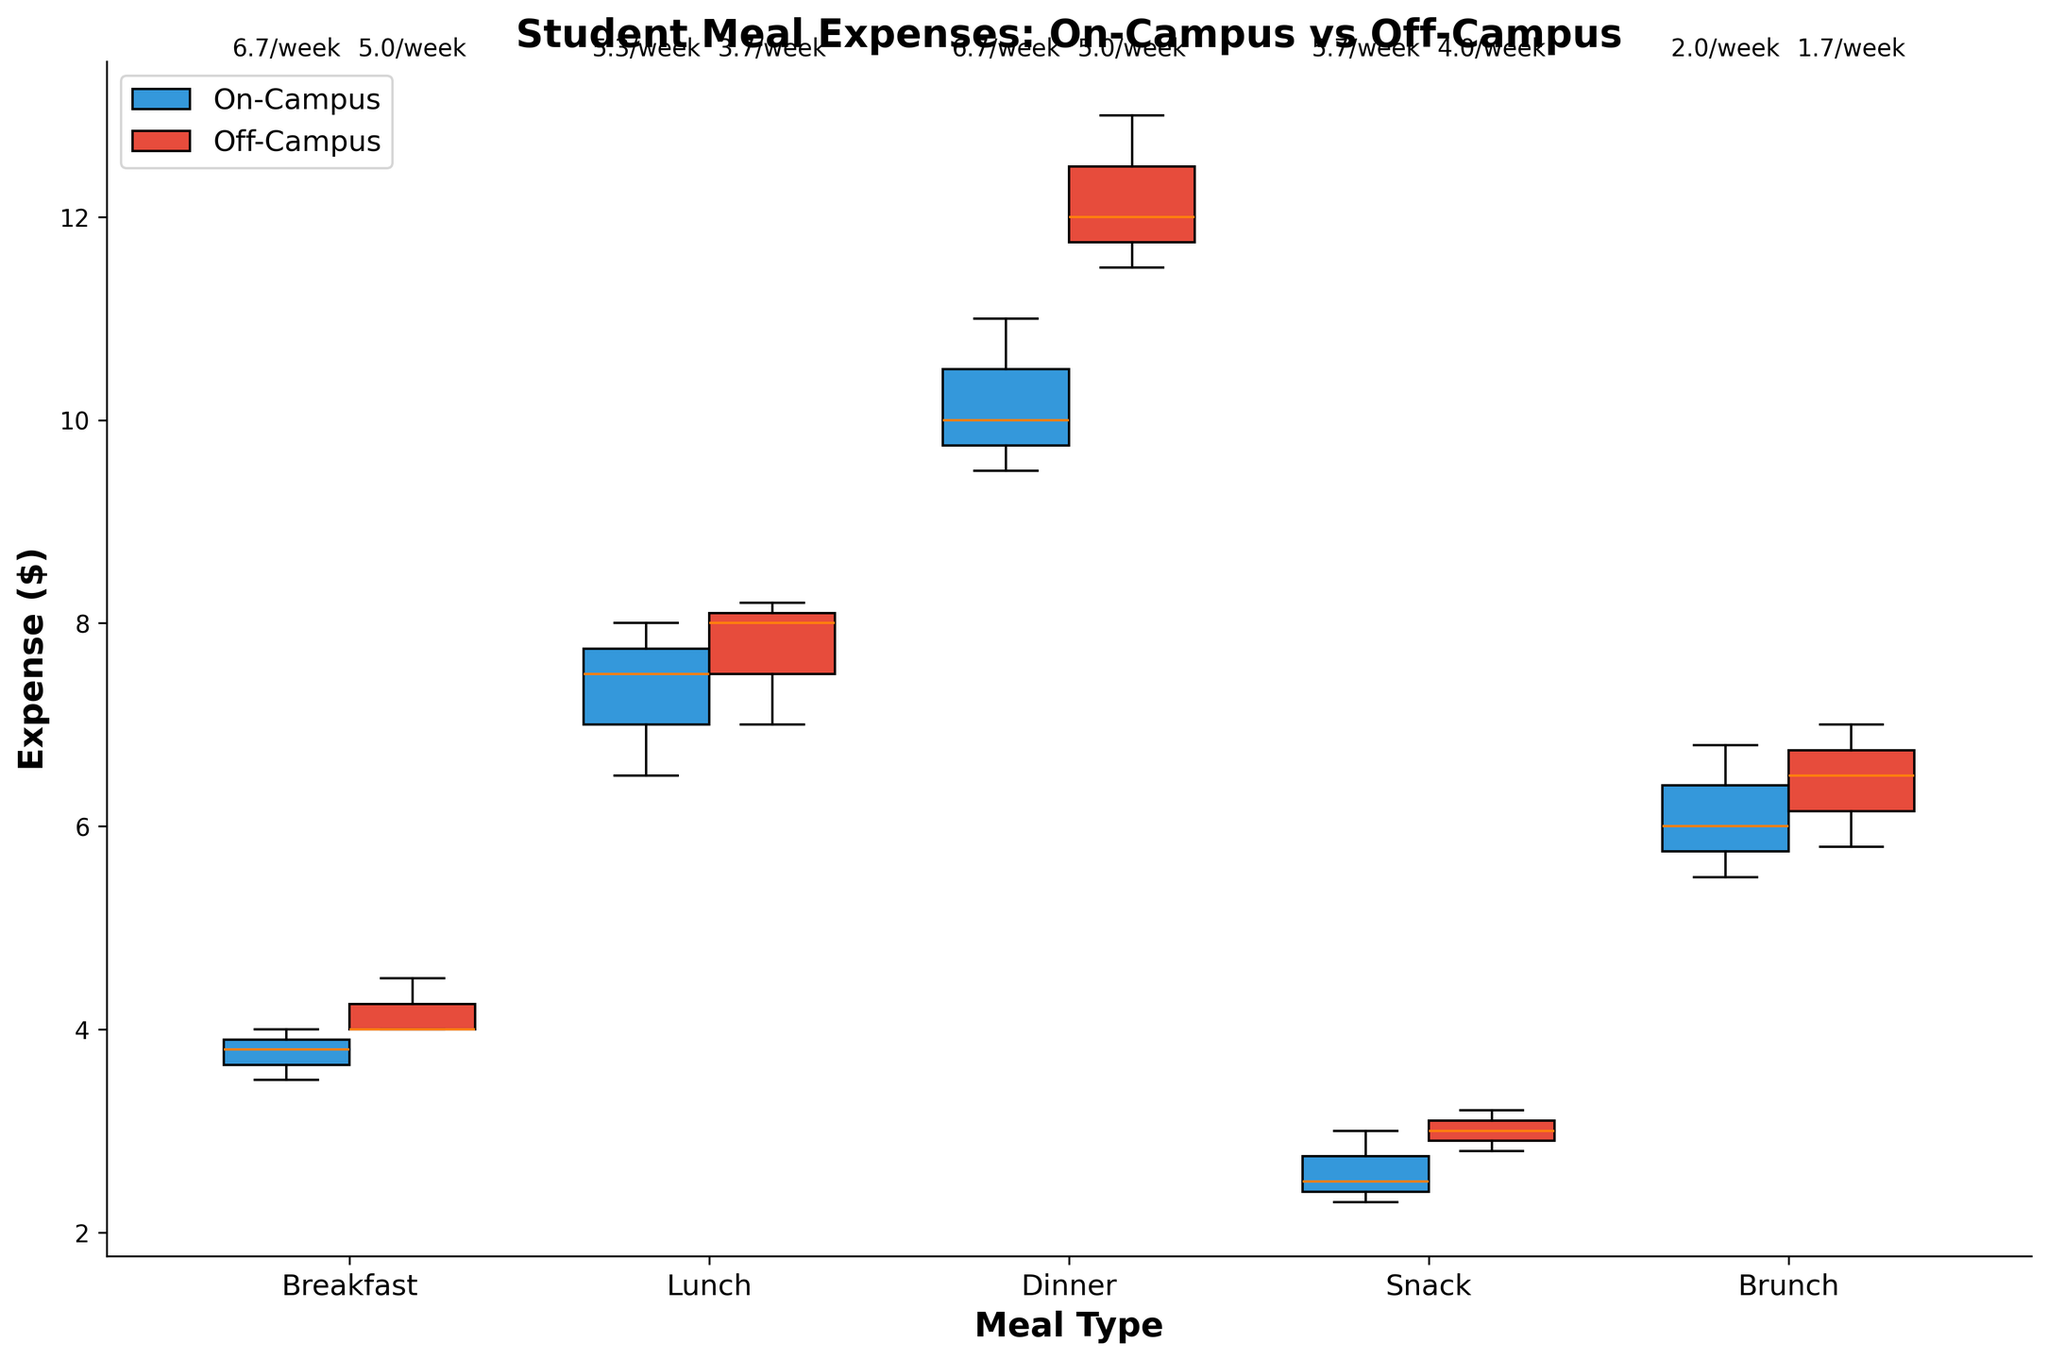What's the title of the figure? The title is at the top of the figure, bold and in a slightly larger font size. The words used indicate the topic of the comparison.
Answer: Student Meal Expenses: On-Campus vs Off-Campus Which color represents the on-campus students' expenses? In the figure, the on-campus box plots are filled with one distinct color. This consistent color helps to visually separate the data.
Answer: Blue Which meal type has the highest expense for off-campus students? Look at the red (off-campus) box plots. Identify which meal type appears at the highest expense level. The height of the box plot indicates the expense.
Answer: Dinner What is the median expense for on-campus lunch? Find the blue box plot for lunch. The median is represented by the line inside the box.
Answer: Around $7.5 Compare the frequency per week of breakfasts for on-campus and off-campus students. Check the text above each corresponding box plot for breakfast. Compare the numbers shown for both on-campus (left side) and off-campus (right side).
Answer: On-Campus: 6.7, Off-Campus: 5 Which meals do off-campus students spend more on compared to on-campus students? Compare the relative heights of the red and blue box plots for each meal type. Higher red box plots indicate higher expenses for off-campus students.
Answer: Breakfast, Dinner, Snack, Brunch How many meal types are compared in the figure? Count the different meal types listed on the x-axis. Each occupies a distinct position on the axis.
Answer: 5 For which meal type are the expenses most similar between on-campus and off-campus students? Look for meal types where the blue and red box plots are closest in position and distribution. The less the gap, the more similar the expenses.
Answer: Lunch What is the average frequency per week for snacks among off-campus students? Locate the text above the box plot for off-campus snacks. This text details the frequency per week directly.
Answer: 4.0 